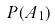Convert formula to latex. <formula><loc_0><loc_0><loc_500><loc_500>P ( A _ { 1 } )</formula> 